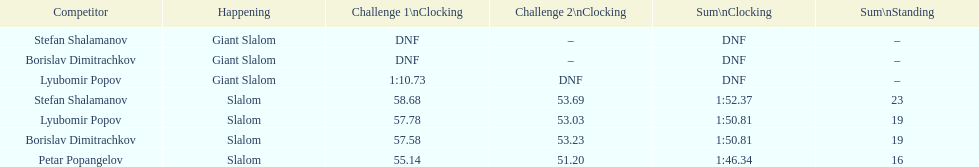What is the rank number of stefan shalamanov in the slalom event 23. 